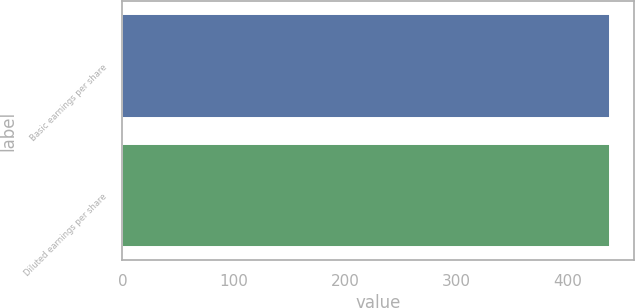Convert chart to OTSL. <chart><loc_0><loc_0><loc_500><loc_500><bar_chart><fcel>Basic earnings per share<fcel>Diluted earnings per share<nl><fcel>437.6<fcel>437.7<nl></chart> 